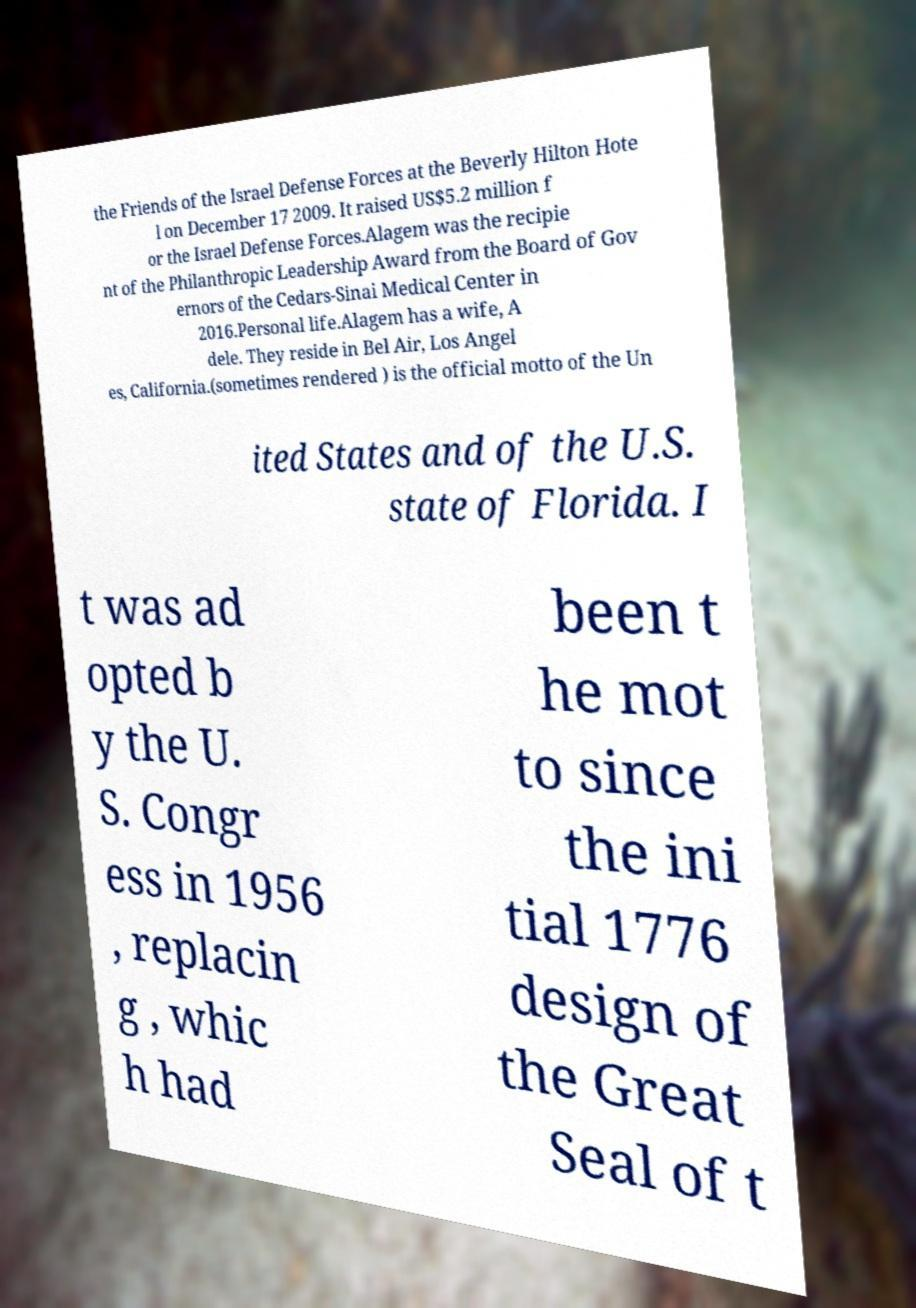Please read and relay the text visible in this image. What does it say? the Friends of the Israel Defense Forces at the Beverly Hilton Hote l on December 17 2009. It raised US$5.2 million f or the Israel Defense Forces.Alagem was the recipie nt of the Philanthropic Leadership Award from the Board of Gov ernors of the Cedars-Sinai Medical Center in 2016.Personal life.Alagem has a wife, A dele. They reside in Bel Air, Los Angel es, California.(sometimes rendered ) is the official motto of the Un ited States and of the U.S. state of Florida. I t was ad opted b y the U. S. Congr ess in 1956 , replacin g , whic h had been t he mot to since the ini tial 1776 design of the Great Seal of t 